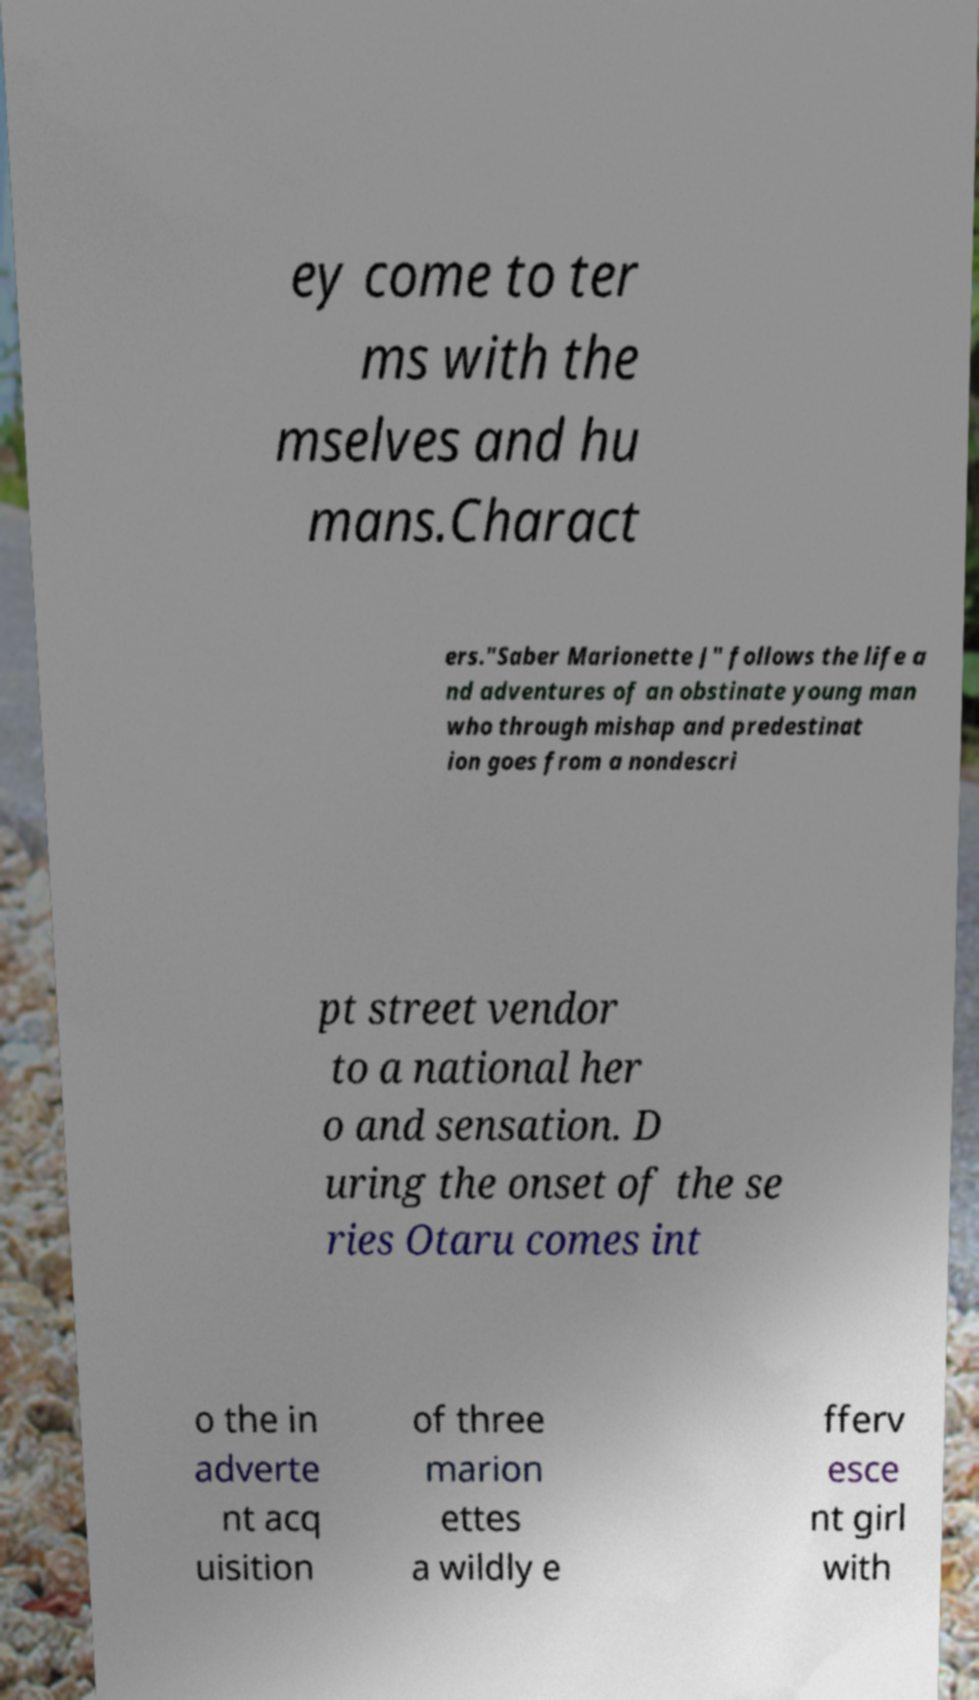Could you assist in decoding the text presented in this image and type it out clearly? ey come to ter ms with the mselves and hu mans.Charact ers."Saber Marionette J" follows the life a nd adventures of an obstinate young man who through mishap and predestinat ion goes from a nondescri pt street vendor to a national her o and sensation. D uring the onset of the se ries Otaru comes int o the in adverte nt acq uisition of three marion ettes a wildly e fferv esce nt girl with 